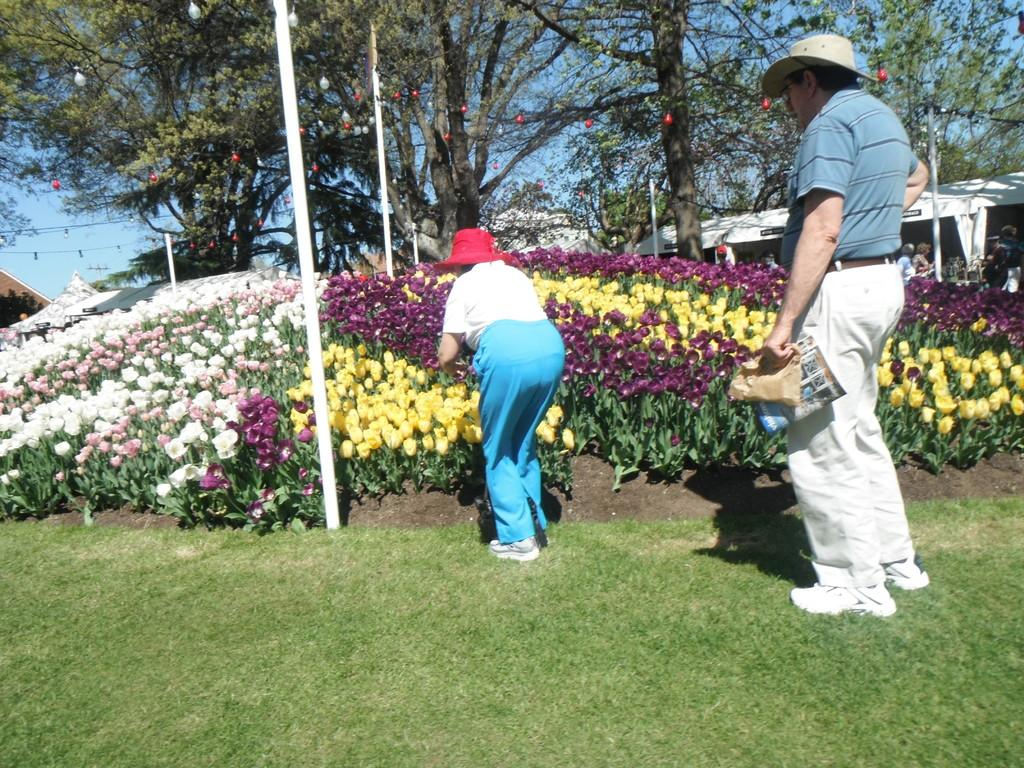Who or what is present in the image? There are people in the image. What can be seen in front of the people? There are plants and flowers in front of the people. What is visible in the background of the image? There are trees in the background of the image. What structures can be seen in the image? There are poles visible in the image. What type of glass is being blown by the people in the image? There is no glass or glass-blowing activity present in the image. 